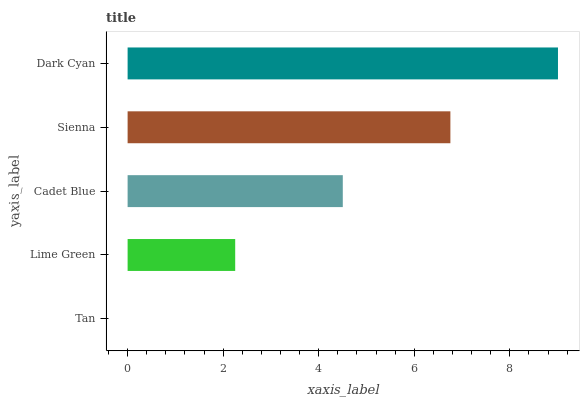Is Tan the minimum?
Answer yes or no. Yes. Is Dark Cyan the maximum?
Answer yes or no. Yes. Is Lime Green the minimum?
Answer yes or no. No. Is Lime Green the maximum?
Answer yes or no. No. Is Lime Green greater than Tan?
Answer yes or no. Yes. Is Tan less than Lime Green?
Answer yes or no. Yes. Is Tan greater than Lime Green?
Answer yes or no. No. Is Lime Green less than Tan?
Answer yes or no. No. Is Cadet Blue the high median?
Answer yes or no. Yes. Is Cadet Blue the low median?
Answer yes or no. Yes. Is Lime Green the high median?
Answer yes or no. No. Is Dark Cyan the low median?
Answer yes or no. No. 